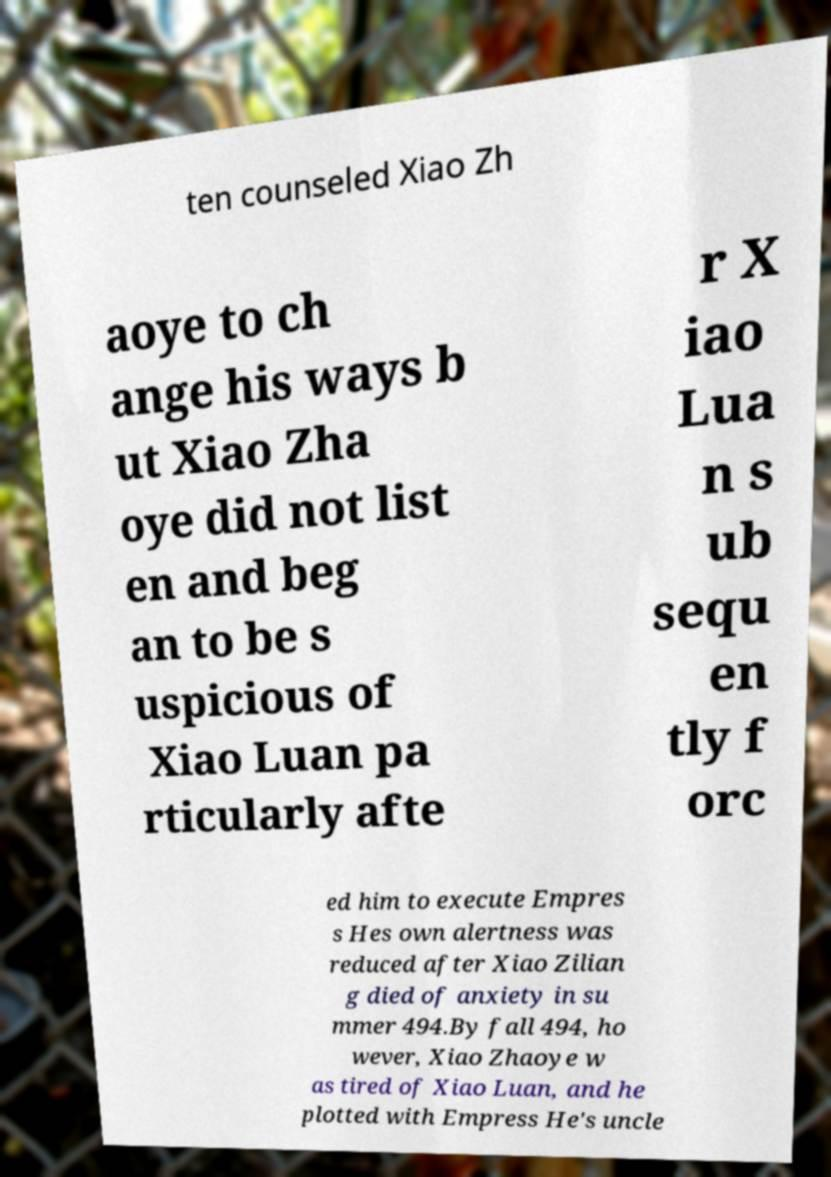What messages or text are displayed in this image? I need them in a readable, typed format. ten counseled Xiao Zh aoye to ch ange his ways b ut Xiao Zha oye did not list en and beg an to be s uspicious of Xiao Luan pa rticularly afte r X iao Lua n s ub sequ en tly f orc ed him to execute Empres s Hes own alertness was reduced after Xiao Zilian g died of anxiety in su mmer 494.By fall 494, ho wever, Xiao Zhaoye w as tired of Xiao Luan, and he plotted with Empress He's uncle 